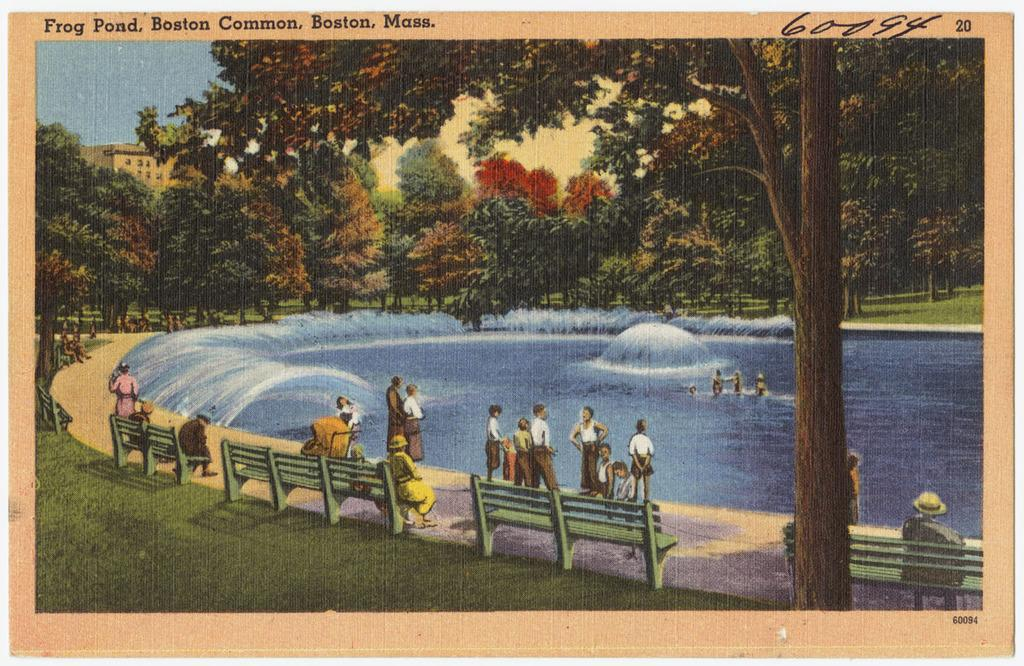<image>
Give a short and clear explanation of the subsequent image. A post card from Frog Pond, Boston Commons, Boston, Mass. 